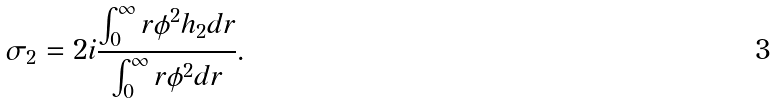Convert formula to latex. <formula><loc_0><loc_0><loc_500><loc_500>\sigma _ { 2 } = 2 i \frac { \int _ { 0 } ^ { \infty } r \phi ^ { 2 } h _ { 2 } d r } { \int _ { 0 } ^ { \infty } r \phi ^ { 2 } d r } .</formula> 